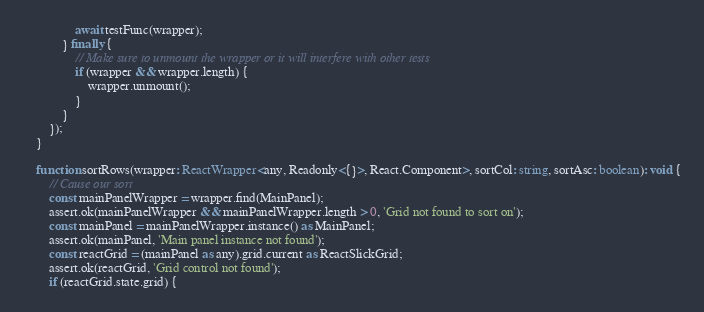Convert code to text. <code><loc_0><loc_0><loc_500><loc_500><_TypeScript_>                await testFunc(wrapper);
            } finally {
                // Make sure to unmount the wrapper or it will interfere with other tests
                if (wrapper && wrapper.length) {
                    wrapper.unmount();
                }
            }
        });
    }

    function sortRows(wrapper: ReactWrapper<any, Readonly<{}>, React.Component>, sortCol: string, sortAsc: boolean): void {
        // Cause our sort
        const mainPanelWrapper = wrapper.find(MainPanel);
        assert.ok(mainPanelWrapper && mainPanelWrapper.length > 0, 'Grid not found to sort on');
        const mainPanel = mainPanelWrapper.instance() as MainPanel;
        assert.ok(mainPanel, 'Main panel instance not found');
        const reactGrid = (mainPanel as any).grid.current as ReactSlickGrid;
        assert.ok(reactGrid, 'Grid control not found');
        if (reactGrid.state.grid) {</code> 